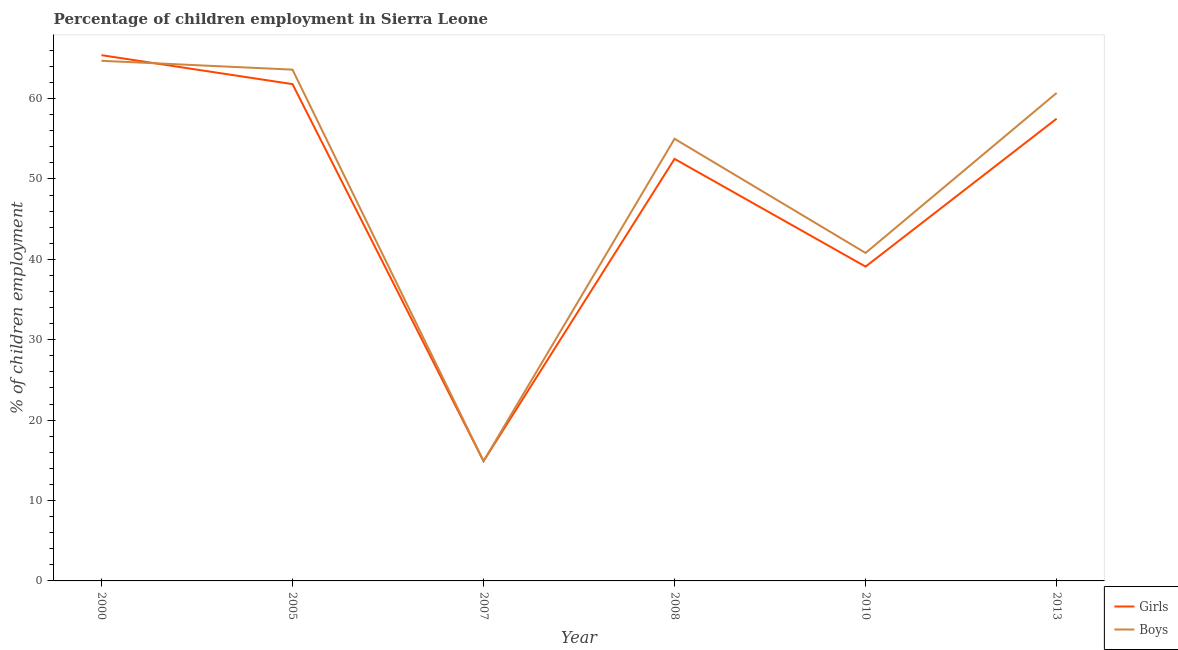Does the line corresponding to percentage of employed boys intersect with the line corresponding to percentage of employed girls?
Your answer should be very brief. Yes. What is the percentage of employed girls in 2000?
Your response must be concise. 65.4. Across all years, what is the maximum percentage of employed girls?
Your answer should be compact. 65.4. In which year was the percentage of employed boys maximum?
Make the answer very short. 2000. In which year was the percentage of employed girls minimum?
Provide a short and direct response. 2007. What is the total percentage of employed boys in the graph?
Ensure brevity in your answer.  299.7. What is the difference between the percentage of employed girls in 2005 and that in 2007?
Provide a short and direct response. 46.9. What is the difference between the percentage of employed boys in 2013 and the percentage of employed girls in 2010?
Ensure brevity in your answer.  21.6. What is the average percentage of employed boys per year?
Make the answer very short. 49.95. In how many years, is the percentage of employed boys greater than 6 %?
Your answer should be compact. 6. What is the ratio of the percentage of employed boys in 2000 to that in 2007?
Your answer should be very brief. 4.34. What is the difference between the highest and the second highest percentage of employed girls?
Ensure brevity in your answer.  3.6. What is the difference between the highest and the lowest percentage of employed girls?
Offer a terse response. 50.5. In how many years, is the percentage of employed girls greater than the average percentage of employed girls taken over all years?
Ensure brevity in your answer.  4. Is the sum of the percentage of employed boys in 2005 and 2010 greater than the maximum percentage of employed girls across all years?
Offer a very short reply. Yes. How many lines are there?
Offer a terse response. 2. Does the graph contain any zero values?
Your answer should be compact. No. What is the title of the graph?
Keep it short and to the point. Percentage of children employment in Sierra Leone. What is the label or title of the Y-axis?
Provide a short and direct response. % of children employment. What is the % of children employment in Girls in 2000?
Keep it short and to the point. 65.4. What is the % of children employment of Boys in 2000?
Your answer should be very brief. 64.7. What is the % of children employment in Girls in 2005?
Keep it short and to the point. 61.8. What is the % of children employment in Boys in 2005?
Provide a succinct answer. 63.6. What is the % of children employment of Girls in 2007?
Ensure brevity in your answer.  14.9. What is the % of children employment in Girls in 2008?
Offer a terse response. 52.5. What is the % of children employment of Boys in 2008?
Provide a succinct answer. 55. What is the % of children employment of Girls in 2010?
Your response must be concise. 39.1. What is the % of children employment of Boys in 2010?
Keep it short and to the point. 40.8. What is the % of children employment in Girls in 2013?
Your answer should be very brief. 57.5. What is the % of children employment in Boys in 2013?
Offer a very short reply. 60.7. Across all years, what is the maximum % of children employment in Girls?
Your answer should be very brief. 65.4. Across all years, what is the maximum % of children employment of Boys?
Your answer should be compact. 64.7. Across all years, what is the minimum % of children employment in Boys?
Provide a succinct answer. 14.9. What is the total % of children employment in Girls in the graph?
Your response must be concise. 291.2. What is the total % of children employment in Boys in the graph?
Offer a very short reply. 299.7. What is the difference between the % of children employment of Girls in 2000 and that in 2005?
Offer a terse response. 3.6. What is the difference between the % of children employment of Boys in 2000 and that in 2005?
Keep it short and to the point. 1.1. What is the difference between the % of children employment of Girls in 2000 and that in 2007?
Offer a terse response. 50.5. What is the difference between the % of children employment of Boys in 2000 and that in 2007?
Keep it short and to the point. 49.8. What is the difference between the % of children employment of Boys in 2000 and that in 2008?
Give a very brief answer. 9.7. What is the difference between the % of children employment in Girls in 2000 and that in 2010?
Offer a terse response. 26.3. What is the difference between the % of children employment in Boys in 2000 and that in 2010?
Provide a succinct answer. 23.9. What is the difference between the % of children employment of Girls in 2000 and that in 2013?
Give a very brief answer. 7.9. What is the difference between the % of children employment of Boys in 2000 and that in 2013?
Make the answer very short. 4. What is the difference between the % of children employment in Girls in 2005 and that in 2007?
Your response must be concise. 46.9. What is the difference between the % of children employment of Boys in 2005 and that in 2007?
Your answer should be compact. 48.7. What is the difference between the % of children employment of Girls in 2005 and that in 2008?
Make the answer very short. 9.3. What is the difference between the % of children employment of Girls in 2005 and that in 2010?
Keep it short and to the point. 22.7. What is the difference between the % of children employment in Boys in 2005 and that in 2010?
Offer a terse response. 22.8. What is the difference between the % of children employment in Girls in 2005 and that in 2013?
Give a very brief answer. 4.3. What is the difference between the % of children employment of Boys in 2005 and that in 2013?
Your answer should be very brief. 2.9. What is the difference between the % of children employment of Girls in 2007 and that in 2008?
Provide a short and direct response. -37.6. What is the difference between the % of children employment in Boys in 2007 and that in 2008?
Provide a short and direct response. -40.1. What is the difference between the % of children employment of Girls in 2007 and that in 2010?
Provide a short and direct response. -24.2. What is the difference between the % of children employment in Boys in 2007 and that in 2010?
Give a very brief answer. -25.9. What is the difference between the % of children employment in Girls in 2007 and that in 2013?
Your answer should be compact. -42.6. What is the difference between the % of children employment in Boys in 2007 and that in 2013?
Keep it short and to the point. -45.8. What is the difference between the % of children employment of Girls in 2008 and that in 2010?
Your response must be concise. 13.4. What is the difference between the % of children employment in Girls in 2008 and that in 2013?
Give a very brief answer. -5. What is the difference between the % of children employment in Girls in 2010 and that in 2013?
Make the answer very short. -18.4. What is the difference between the % of children employment of Boys in 2010 and that in 2013?
Offer a terse response. -19.9. What is the difference between the % of children employment in Girls in 2000 and the % of children employment in Boys in 2007?
Provide a succinct answer. 50.5. What is the difference between the % of children employment of Girls in 2000 and the % of children employment of Boys in 2010?
Provide a short and direct response. 24.6. What is the difference between the % of children employment in Girls in 2005 and the % of children employment in Boys in 2007?
Offer a very short reply. 46.9. What is the difference between the % of children employment of Girls in 2005 and the % of children employment of Boys in 2008?
Keep it short and to the point. 6.8. What is the difference between the % of children employment of Girls in 2007 and the % of children employment of Boys in 2008?
Offer a terse response. -40.1. What is the difference between the % of children employment of Girls in 2007 and the % of children employment of Boys in 2010?
Provide a short and direct response. -25.9. What is the difference between the % of children employment of Girls in 2007 and the % of children employment of Boys in 2013?
Offer a terse response. -45.8. What is the difference between the % of children employment in Girls in 2010 and the % of children employment in Boys in 2013?
Provide a short and direct response. -21.6. What is the average % of children employment of Girls per year?
Offer a terse response. 48.53. What is the average % of children employment in Boys per year?
Keep it short and to the point. 49.95. In the year 2013, what is the difference between the % of children employment of Girls and % of children employment of Boys?
Make the answer very short. -3.2. What is the ratio of the % of children employment of Girls in 2000 to that in 2005?
Ensure brevity in your answer.  1.06. What is the ratio of the % of children employment in Boys in 2000 to that in 2005?
Keep it short and to the point. 1.02. What is the ratio of the % of children employment of Girls in 2000 to that in 2007?
Make the answer very short. 4.39. What is the ratio of the % of children employment in Boys in 2000 to that in 2007?
Offer a terse response. 4.34. What is the ratio of the % of children employment in Girls in 2000 to that in 2008?
Offer a very short reply. 1.25. What is the ratio of the % of children employment in Boys in 2000 to that in 2008?
Give a very brief answer. 1.18. What is the ratio of the % of children employment in Girls in 2000 to that in 2010?
Provide a succinct answer. 1.67. What is the ratio of the % of children employment in Boys in 2000 to that in 2010?
Your answer should be compact. 1.59. What is the ratio of the % of children employment of Girls in 2000 to that in 2013?
Make the answer very short. 1.14. What is the ratio of the % of children employment in Boys in 2000 to that in 2013?
Make the answer very short. 1.07. What is the ratio of the % of children employment in Girls in 2005 to that in 2007?
Make the answer very short. 4.15. What is the ratio of the % of children employment of Boys in 2005 to that in 2007?
Your response must be concise. 4.27. What is the ratio of the % of children employment in Girls in 2005 to that in 2008?
Give a very brief answer. 1.18. What is the ratio of the % of children employment in Boys in 2005 to that in 2008?
Your answer should be very brief. 1.16. What is the ratio of the % of children employment in Girls in 2005 to that in 2010?
Offer a terse response. 1.58. What is the ratio of the % of children employment of Boys in 2005 to that in 2010?
Your response must be concise. 1.56. What is the ratio of the % of children employment of Girls in 2005 to that in 2013?
Ensure brevity in your answer.  1.07. What is the ratio of the % of children employment of Boys in 2005 to that in 2013?
Your response must be concise. 1.05. What is the ratio of the % of children employment of Girls in 2007 to that in 2008?
Your answer should be very brief. 0.28. What is the ratio of the % of children employment of Boys in 2007 to that in 2008?
Keep it short and to the point. 0.27. What is the ratio of the % of children employment in Girls in 2007 to that in 2010?
Your answer should be very brief. 0.38. What is the ratio of the % of children employment in Boys in 2007 to that in 2010?
Keep it short and to the point. 0.37. What is the ratio of the % of children employment of Girls in 2007 to that in 2013?
Give a very brief answer. 0.26. What is the ratio of the % of children employment of Boys in 2007 to that in 2013?
Keep it short and to the point. 0.25. What is the ratio of the % of children employment of Girls in 2008 to that in 2010?
Your answer should be compact. 1.34. What is the ratio of the % of children employment of Boys in 2008 to that in 2010?
Ensure brevity in your answer.  1.35. What is the ratio of the % of children employment of Boys in 2008 to that in 2013?
Your answer should be compact. 0.91. What is the ratio of the % of children employment in Girls in 2010 to that in 2013?
Provide a short and direct response. 0.68. What is the ratio of the % of children employment of Boys in 2010 to that in 2013?
Keep it short and to the point. 0.67. What is the difference between the highest and the second highest % of children employment of Girls?
Give a very brief answer. 3.6. What is the difference between the highest and the second highest % of children employment in Boys?
Provide a short and direct response. 1.1. What is the difference between the highest and the lowest % of children employment in Girls?
Make the answer very short. 50.5. What is the difference between the highest and the lowest % of children employment in Boys?
Your response must be concise. 49.8. 